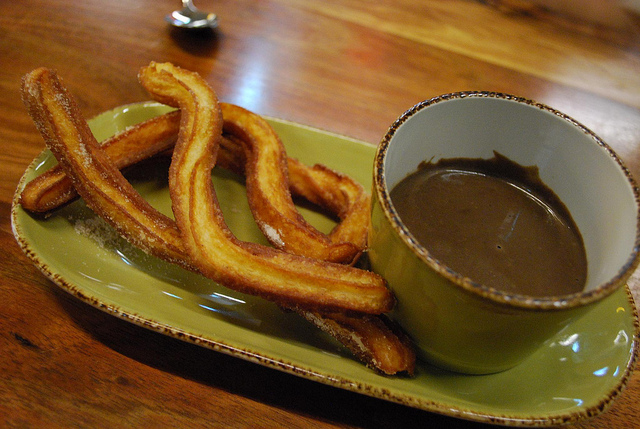Describe the texture of the food on the plate. The churros appear to have a crispy exterior with a soft, fluffy interior. The sugar on the surface adds a slight crunchy texture. What might this scene smell like if you were here? It would likely smell delightful, with the sweet aroma of cinnamon and sugar from the churros and the rich scent of chocolate from the mug. Imagine you're writing a food blog. Describe this dish as if you were recommending it to readers. Feast your eyes on this delightful plate of churros and chocolate! These golden, crispy churros are generously coated with a sweet layer of sugar, making each bite a heavenly experience. Paired with a cup of rich, decadent chocolate for dipping, this combination is perfect for satisfying your sweet tooth. Whether you're looking for a treat to enjoy with your morning coffee or a dessert to cap off your evening, this churro and chocolate duo is sure to delight your senses. 